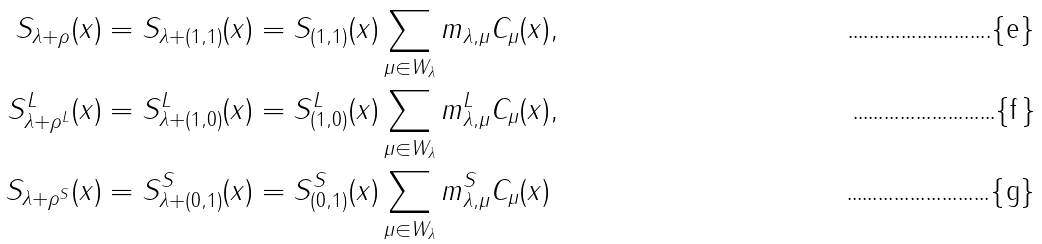Convert formula to latex. <formula><loc_0><loc_0><loc_500><loc_500>S _ { \lambda + \rho } ( x ) & = S _ { \lambda + ( 1 , 1 ) } ( x ) = S _ { ( 1 , 1 ) } ( x ) \sum _ { \mu \in W _ { \lambda } } m _ { \lambda , \mu } C _ { \mu } ( x ) , \\ S ^ { L } _ { \lambda + \rho ^ { L } } ( x ) & = S ^ { L } _ { \lambda + ( 1 , 0 ) } ( x ) = S ^ { L } _ { ( 1 , 0 ) } ( x ) \sum _ { \mu \in W _ { \lambda } } m ^ { L } _ { \lambda , \mu } C _ { \mu } ( x ) , \\ S _ { \lambda + \rho ^ { S } } ( x ) & = S ^ { S } _ { \lambda + ( 0 , 1 ) } ( x ) = S ^ { S } _ { ( 0 , 1 ) } ( x ) \sum _ { \mu \in W _ { \lambda } } m ^ { S } _ { \lambda , \mu } C _ { \mu } ( x )</formula> 